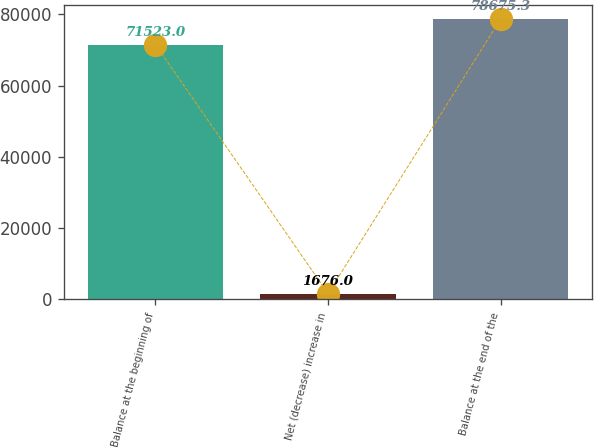Convert chart to OTSL. <chart><loc_0><loc_0><loc_500><loc_500><bar_chart><fcel>Balance at the beginning of<fcel>Net (decrease) increase in<fcel>Balance at the end of the<nl><fcel>71523<fcel>1676<fcel>78675.3<nl></chart> 